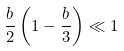Convert formula to latex. <formula><loc_0><loc_0><loc_500><loc_500>\frac { b } { 2 } \left ( 1 - \frac { b } { 3 } \right ) \ll 1</formula> 